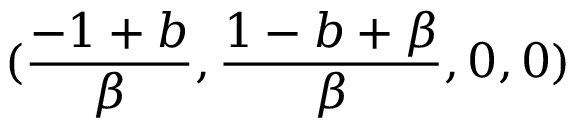<formula> <loc_0><loc_0><loc_500><loc_500>( \frac { - 1 + b } { \beta } , \frac { 1 - b + \beta } { \beta } , 0 , 0 )</formula> 